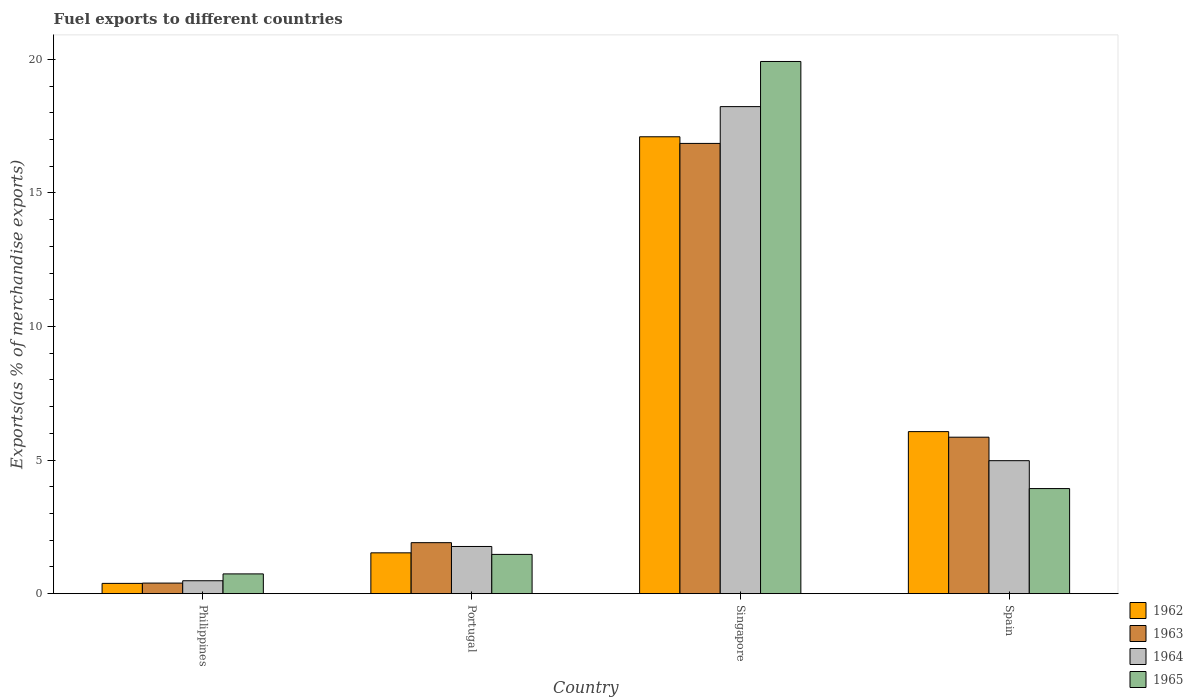How many different coloured bars are there?
Give a very brief answer. 4. How many groups of bars are there?
Your response must be concise. 4. Are the number of bars on each tick of the X-axis equal?
Your answer should be very brief. Yes. In how many cases, is the number of bars for a given country not equal to the number of legend labels?
Your answer should be very brief. 0. What is the percentage of exports to different countries in 1965 in Philippines?
Offer a very short reply. 0.74. Across all countries, what is the maximum percentage of exports to different countries in 1962?
Your answer should be compact. 17.1. Across all countries, what is the minimum percentage of exports to different countries in 1963?
Your response must be concise. 0.4. In which country was the percentage of exports to different countries in 1963 maximum?
Make the answer very short. Singapore. In which country was the percentage of exports to different countries in 1962 minimum?
Keep it short and to the point. Philippines. What is the total percentage of exports to different countries in 1962 in the graph?
Keep it short and to the point. 25.08. What is the difference between the percentage of exports to different countries in 1962 in Philippines and that in Portugal?
Provide a short and direct response. -1.14. What is the difference between the percentage of exports to different countries in 1962 in Philippines and the percentage of exports to different countries in 1963 in Portugal?
Provide a succinct answer. -1.52. What is the average percentage of exports to different countries in 1963 per country?
Offer a terse response. 6.25. What is the difference between the percentage of exports to different countries of/in 1965 and percentage of exports to different countries of/in 1962 in Philippines?
Your answer should be compact. 0.35. In how many countries, is the percentage of exports to different countries in 1962 greater than 7 %?
Ensure brevity in your answer.  1. What is the ratio of the percentage of exports to different countries in 1964 in Portugal to that in Singapore?
Your answer should be compact. 0.1. Is the difference between the percentage of exports to different countries in 1965 in Portugal and Singapore greater than the difference between the percentage of exports to different countries in 1962 in Portugal and Singapore?
Keep it short and to the point. No. What is the difference between the highest and the second highest percentage of exports to different countries in 1964?
Provide a succinct answer. -16.47. What is the difference between the highest and the lowest percentage of exports to different countries in 1965?
Ensure brevity in your answer.  19.18. In how many countries, is the percentage of exports to different countries in 1965 greater than the average percentage of exports to different countries in 1965 taken over all countries?
Keep it short and to the point. 1. Is the sum of the percentage of exports to different countries in 1962 in Philippines and Portugal greater than the maximum percentage of exports to different countries in 1965 across all countries?
Ensure brevity in your answer.  No. Is it the case that in every country, the sum of the percentage of exports to different countries in 1962 and percentage of exports to different countries in 1965 is greater than the sum of percentage of exports to different countries in 1963 and percentage of exports to different countries in 1964?
Keep it short and to the point. No. Is it the case that in every country, the sum of the percentage of exports to different countries in 1963 and percentage of exports to different countries in 1962 is greater than the percentage of exports to different countries in 1965?
Your answer should be compact. Yes. How many bars are there?
Give a very brief answer. 16. How many countries are there in the graph?
Make the answer very short. 4. Does the graph contain any zero values?
Your answer should be very brief. No. What is the title of the graph?
Keep it short and to the point. Fuel exports to different countries. Does "1990" appear as one of the legend labels in the graph?
Provide a succinct answer. No. What is the label or title of the X-axis?
Your response must be concise. Country. What is the label or title of the Y-axis?
Provide a short and direct response. Exports(as % of merchandise exports). What is the Exports(as % of merchandise exports) in 1962 in Philippines?
Offer a terse response. 0.38. What is the Exports(as % of merchandise exports) in 1963 in Philippines?
Provide a short and direct response. 0.4. What is the Exports(as % of merchandise exports) in 1964 in Philippines?
Give a very brief answer. 0.48. What is the Exports(as % of merchandise exports) in 1965 in Philippines?
Offer a terse response. 0.74. What is the Exports(as % of merchandise exports) of 1962 in Portugal?
Make the answer very short. 1.53. What is the Exports(as % of merchandise exports) in 1963 in Portugal?
Ensure brevity in your answer.  1.91. What is the Exports(as % of merchandise exports) in 1964 in Portugal?
Ensure brevity in your answer.  1.77. What is the Exports(as % of merchandise exports) in 1965 in Portugal?
Offer a very short reply. 1.47. What is the Exports(as % of merchandise exports) in 1962 in Singapore?
Ensure brevity in your answer.  17.1. What is the Exports(as % of merchandise exports) in 1963 in Singapore?
Offer a terse response. 16.85. What is the Exports(as % of merchandise exports) of 1964 in Singapore?
Give a very brief answer. 18.23. What is the Exports(as % of merchandise exports) of 1965 in Singapore?
Keep it short and to the point. 19.92. What is the Exports(as % of merchandise exports) in 1962 in Spain?
Provide a succinct answer. 6.07. What is the Exports(as % of merchandise exports) of 1963 in Spain?
Your answer should be very brief. 5.86. What is the Exports(as % of merchandise exports) of 1964 in Spain?
Provide a succinct answer. 4.98. What is the Exports(as % of merchandise exports) in 1965 in Spain?
Keep it short and to the point. 3.93. Across all countries, what is the maximum Exports(as % of merchandise exports) in 1962?
Offer a very short reply. 17.1. Across all countries, what is the maximum Exports(as % of merchandise exports) of 1963?
Your response must be concise. 16.85. Across all countries, what is the maximum Exports(as % of merchandise exports) in 1964?
Your answer should be very brief. 18.23. Across all countries, what is the maximum Exports(as % of merchandise exports) of 1965?
Offer a terse response. 19.92. Across all countries, what is the minimum Exports(as % of merchandise exports) of 1962?
Your answer should be very brief. 0.38. Across all countries, what is the minimum Exports(as % of merchandise exports) of 1963?
Make the answer very short. 0.4. Across all countries, what is the minimum Exports(as % of merchandise exports) in 1964?
Offer a terse response. 0.48. Across all countries, what is the minimum Exports(as % of merchandise exports) in 1965?
Offer a terse response. 0.74. What is the total Exports(as % of merchandise exports) in 1962 in the graph?
Offer a terse response. 25.08. What is the total Exports(as % of merchandise exports) of 1963 in the graph?
Your answer should be very brief. 25.02. What is the total Exports(as % of merchandise exports) in 1964 in the graph?
Keep it short and to the point. 25.46. What is the total Exports(as % of merchandise exports) in 1965 in the graph?
Offer a very short reply. 26.07. What is the difference between the Exports(as % of merchandise exports) of 1962 in Philippines and that in Portugal?
Make the answer very short. -1.14. What is the difference between the Exports(as % of merchandise exports) of 1963 in Philippines and that in Portugal?
Ensure brevity in your answer.  -1.51. What is the difference between the Exports(as % of merchandise exports) in 1964 in Philippines and that in Portugal?
Keep it short and to the point. -1.28. What is the difference between the Exports(as % of merchandise exports) of 1965 in Philippines and that in Portugal?
Offer a terse response. -0.73. What is the difference between the Exports(as % of merchandise exports) in 1962 in Philippines and that in Singapore?
Make the answer very short. -16.72. What is the difference between the Exports(as % of merchandise exports) of 1963 in Philippines and that in Singapore?
Provide a short and direct response. -16.46. What is the difference between the Exports(as % of merchandise exports) in 1964 in Philippines and that in Singapore?
Make the answer very short. -17.75. What is the difference between the Exports(as % of merchandise exports) of 1965 in Philippines and that in Singapore?
Your response must be concise. -19.18. What is the difference between the Exports(as % of merchandise exports) of 1962 in Philippines and that in Spain?
Your answer should be very brief. -5.68. What is the difference between the Exports(as % of merchandise exports) of 1963 in Philippines and that in Spain?
Provide a short and direct response. -5.46. What is the difference between the Exports(as % of merchandise exports) in 1964 in Philippines and that in Spain?
Provide a succinct answer. -4.49. What is the difference between the Exports(as % of merchandise exports) of 1965 in Philippines and that in Spain?
Provide a short and direct response. -3.19. What is the difference between the Exports(as % of merchandise exports) of 1962 in Portugal and that in Singapore?
Keep it short and to the point. -15.58. What is the difference between the Exports(as % of merchandise exports) in 1963 in Portugal and that in Singapore?
Ensure brevity in your answer.  -14.95. What is the difference between the Exports(as % of merchandise exports) of 1964 in Portugal and that in Singapore?
Offer a very short reply. -16.47. What is the difference between the Exports(as % of merchandise exports) in 1965 in Portugal and that in Singapore?
Your answer should be very brief. -18.45. What is the difference between the Exports(as % of merchandise exports) in 1962 in Portugal and that in Spain?
Give a very brief answer. -4.54. What is the difference between the Exports(as % of merchandise exports) in 1963 in Portugal and that in Spain?
Offer a very short reply. -3.95. What is the difference between the Exports(as % of merchandise exports) of 1964 in Portugal and that in Spain?
Keep it short and to the point. -3.21. What is the difference between the Exports(as % of merchandise exports) in 1965 in Portugal and that in Spain?
Your response must be concise. -2.46. What is the difference between the Exports(as % of merchandise exports) in 1962 in Singapore and that in Spain?
Provide a short and direct response. 11.04. What is the difference between the Exports(as % of merchandise exports) in 1963 in Singapore and that in Spain?
Your answer should be compact. 11. What is the difference between the Exports(as % of merchandise exports) of 1964 in Singapore and that in Spain?
Provide a succinct answer. 13.25. What is the difference between the Exports(as % of merchandise exports) in 1965 in Singapore and that in Spain?
Offer a terse response. 15.99. What is the difference between the Exports(as % of merchandise exports) of 1962 in Philippines and the Exports(as % of merchandise exports) of 1963 in Portugal?
Your answer should be compact. -1.52. What is the difference between the Exports(as % of merchandise exports) of 1962 in Philippines and the Exports(as % of merchandise exports) of 1964 in Portugal?
Your answer should be compact. -1.38. What is the difference between the Exports(as % of merchandise exports) of 1962 in Philippines and the Exports(as % of merchandise exports) of 1965 in Portugal?
Provide a short and direct response. -1.08. What is the difference between the Exports(as % of merchandise exports) of 1963 in Philippines and the Exports(as % of merchandise exports) of 1964 in Portugal?
Ensure brevity in your answer.  -1.37. What is the difference between the Exports(as % of merchandise exports) in 1963 in Philippines and the Exports(as % of merchandise exports) in 1965 in Portugal?
Make the answer very short. -1.07. What is the difference between the Exports(as % of merchandise exports) of 1964 in Philippines and the Exports(as % of merchandise exports) of 1965 in Portugal?
Provide a short and direct response. -0.99. What is the difference between the Exports(as % of merchandise exports) of 1962 in Philippines and the Exports(as % of merchandise exports) of 1963 in Singapore?
Your answer should be compact. -16.47. What is the difference between the Exports(as % of merchandise exports) of 1962 in Philippines and the Exports(as % of merchandise exports) of 1964 in Singapore?
Your response must be concise. -17.85. What is the difference between the Exports(as % of merchandise exports) in 1962 in Philippines and the Exports(as % of merchandise exports) in 1965 in Singapore?
Provide a succinct answer. -19.54. What is the difference between the Exports(as % of merchandise exports) in 1963 in Philippines and the Exports(as % of merchandise exports) in 1964 in Singapore?
Give a very brief answer. -17.84. What is the difference between the Exports(as % of merchandise exports) of 1963 in Philippines and the Exports(as % of merchandise exports) of 1965 in Singapore?
Offer a very short reply. -19.53. What is the difference between the Exports(as % of merchandise exports) in 1964 in Philippines and the Exports(as % of merchandise exports) in 1965 in Singapore?
Provide a short and direct response. -19.44. What is the difference between the Exports(as % of merchandise exports) in 1962 in Philippines and the Exports(as % of merchandise exports) in 1963 in Spain?
Offer a very short reply. -5.47. What is the difference between the Exports(as % of merchandise exports) of 1962 in Philippines and the Exports(as % of merchandise exports) of 1964 in Spain?
Offer a very short reply. -4.59. What is the difference between the Exports(as % of merchandise exports) in 1962 in Philippines and the Exports(as % of merchandise exports) in 1965 in Spain?
Give a very brief answer. -3.55. What is the difference between the Exports(as % of merchandise exports) in 1963 in Philippines and the Exports(as % of merchandise exports) in 1964 in Spain?
Your response must be concise. -4.58. What is the difference between the Exports(as % of merchandise exports) in 1963 in Philippines and the Exports(as % of merchandise exports) in 1965 in Spain?
Ensure brevity in your answer.  -3.54. What is the difference between the Exports(as % of merchandise exports) of 1964 in Philippines and the Exports(as % of merchandise exports) of 1965 in Spain?
Offer a very short reply. -3.45. What is the difference between the Exports(as % of merchandise exports) of 1962 in Portugal and the Exports(as % of merchandise exports) of 1963 in Singapore?
Provide a short and direct response. -15.33. What is the difference between the Exports(as % of merchandise exports) of 1962 in Portugal and the Exports(as % of merchandise exports) of 1964 in Singapore?
Your answer should be very brief. -16.7. What is the difference between the Exports(as % of merchandise exports) of 1962 in Portugal and the Exports(as % of merchandise exports) of 1965 in Singapore?
Your answer should be compact. -18.39. What is the difference between the Exports(as % of merchandise exports) of 1963 in Portugal and the Exports(as % of merchandise exports) of 1964 in Singapore?
Offer a terse response. -16.32. What is the difference between the Exports(as % of merchandise exports) in 1963 in Portugal and the Exports(as % of merchandise exports) in 1965 in Singapore?
Give a very brief answer. -18.01. What is the difference between the Exports(as % of merchandise exports) of 1964 in Portugal and the Exports(as % of merchandise exports) of 1965 in Singapore?
Keep it short and to the point. -18.16. What is the difference between the Exports(as % of merchandise exports) in 1962 in Portugal and the Exports(as % of merchandise exports) in 1963 in Spain?
Your response must be concise. -4.33. What is the difference between the Exports(as % of merchandise exports) of 1962 in Portugal and the Exports(as % of merchandise exports) of 1964 in Spain?
Offer a terse response. -3.45. What is the difference between the Exports(as % of merchandise exports) in 1962 in Portugal and the Exports(as % of merchandise exports) in 1965 in Spain?
Ensure brevity in your answer.  -2.41. What is the difference between the Exports(as % of merchandise exports) in 1963 in Portugal and the Exports(as % of merchandise exports) in 1964 in Spain?
Your answer should be very brief. -3.07. What is the difference between the Exports(as % of merchandise exports) of 1963 in Portugal and the Exports(as % of merchandise exports) of 1965 in Spain?
Provide a short and direct response. -2.03. What is the difference between the Exports(as % of merchandise exports) in 1964 in Portugal and the Exports(as % of merchandise exports) in 1965 in Spain?
Your answer should be very brief. -2.17. What is the difference between the Exports(as % of merchandise exports) in 1962 in Singapore and the Exports(as % of merchandise exports) in 1963 in Spain?
Your answer should be very brief. 11.25. What is the difference between the Exports(as % of merchandise exports) of 1962 in Singapore and the Exports(as % of merchandise exports) of 1964 in Spain?
Make the answer very short. 12.13. What is the difference between the Exports(as % of merchandise exports) of 1962 in Singapore and the Exports(as % of merchandise exports) of 1965 in Spain?
Ensure brevity in your answer.  13.17. What is the difference between the Exports(as % of merchandise exports) in 1963 in Singapore and the Exports(as % of merchandise exports) in 1964 in Spain?
Give a very brief answer. 11.88. What is the difference between the Exports(as % of merchandise exports) in 1963 in Singapore and the Exports(as % of merchandise exports) in 1965 in Spain?
Ensure brevity in your answer.  12.92. What is the difference between the Exports(as % of merchandise exports) in 1964 in Singapore and the Exports(as % of merchandise exports) in 1965 in Spain?
Provide a succinct answer. 14.3. What is the average Exports(as % of merchandise exports) of 1962 per country?
Your response must be concise. 6.27. What is the average Exports(as % of merchandise exports) in 1963 per country?
Give a very brief answer. 6.25. What is the average Exports(as % of merchandise exports) of 1964 per country?
Ensure brevity in your answer.  6.37. What is the average Exports(as % of merchandise exports) in 1965 per country?
Offer a very short reply. 6.52. What is the difference between the Exports(as % of merchandise exports) in 1962 and Exports(as % of merchandise exports) in 1963 in Philippines?
Keep it short and to the point. -0.01. What is the difference between the Exports(as % of merchandise exports) in 1962 and Exports(as % of merchandise exports) in 1964 in Philippines?
Keep it short and to the point. -0.1. What is the difference between the Exports(as % of merchandise exports) in 1962 and Exports(as % of merchandise exports) in 1965 in Philippines?
Your response must be concise. -0.35. What is the difference between the Exports(as % of merchandise exports) of 1963 and Exports(as % of merchandise exports) of 1964 in Philippines?
Offer a terse response. -0.09. What is the difference between the Exports(as % of merchandise exports) of 1963 and Exports(as % of merchandise exports) of 1965 in Philippines?
Your response must be concise. -0.34. What is the difference between the Exports(as % of merchandise exports) of 1964 and Exports(as % of merchandise exports) of 1965 in Philippines?
Offer a terse response. -0.26. What is the difference between the Exports(as % of merchandise exports) in 1962 and Exports(as % of merchandise exports) in 1963 in Portugal?
Your answer should be very brief. -0.38. What is the difference between the Exports(as % of merchandise exports) of 1962 and Exports(as % of merchandise exports) of 1964 in Portugal?
Make the answer very short. -0.24. What is the difference between the Exports(as % of merchandise exports) in 1962 and Exports(as % of merchandise exports) in 1965 in Portugal?
Offer a very short reply. 0.06. What is the difference between the Exports(as % of merchandise exports) of 1963 and Exports(as % of merchandise exports) of 1964 in Portugal?
Offer a terse response. 0.14. What is the difference between the Exports(as % of merchandise exports) of 1963 and Exports(as % of merchandise exports) of 1965 in Portugal?
Your answer should be compact. 0.44. What is the difference between the Exports(as % of merchandise exports) in 1964 and Exports(as % of merchandise exports) in 1965 in Portugal?
Provide a short and direct response. 0.3. What is the difference between the Exports(as % of merchandise exports) of 1962 and Exports(as % of merchandise exports) of 1963 in Singapore?
Give a very brief answer. 0.25. What is the difference between the Exports(as % of merchandise exports) in 1962 and Exports(as % of merchandise exports) in 1964 in Singapore?
Offer a terse response. -1.13. What is the difference between the Exports(as % of merchandise exports) in 1962 and Exports(as % of merchandise exports) in 1965 in Singapore?
Your answer should be very brief. -2.82. What is the difference between the Exports(as % of merchandise exports) in 1963 and Exports(as % of merchandise exports) in 1964 in Singapore?
Provide a succinct answer. -1.38. What is the difference between the Exports(as % of merchandise exports) of 1963 and Exports(as % of merchandise exports) of 1965 in Singapore?
Make the answer very short. -3.07. What is the difference between the Exports(as % of merchandise exports) in 1964 and Exports(as % of merchandise exports) in 1965 in Singapore?
Give a very brief answer. -1.69. What is the difference between the Exports(as % of merchandise exports) of 1962 and Exports(as % of merchandise exports) of 1963 in Spain?
Your answer should be very brief. 0.21. What is the difference between the Exports(as % of merchandise exports) in 1962 and Exports(as % of merchandise exports) in 1964 in Spain?
Your answer should be very brief. 1.09. What is the difference between the Exports(as % of merchandise exports) of 1962 and Exports(as % of merchandise exports) of 1965 in Spain?
Offer a terse response. 2.13. What is the difference between the Exports(as % of merchandise exports) of 1963 and Exports(as % of merchandise exports) of 1964 in Spain?
Offer a very short reply. 0.88. What is the difference between the Exports(as % of merchandise exports) of 1963 and Exports(as % of merchandise exports) of 1965 in Spain?
Your answer should be compact. 1.92. What is the difference between the Exports(as % of merchandise exports) of 1964 and Exports(as % of merchandise exports) of 1965 in Spain?
Provide a short and direct response. 1.04. What is the ratio of the Exports(as % of merchandise exports) in 1962 in Philippines to that in Portugal?
Keep it short and to the point. 0.25. What is the ratio of the Exports(as % of merchandise exports) of 1963 in Philippines to that in Portugal?
Offer a very short reply. 0.21. What is the ratio of the Exports(as % of merchandise exports) of 1964 in Philippines to that in Portugal?
Your answer should be compact. 0.27. What is the ratio of the Exports(as % of merchandise exports) in 1965 in Philippines to that in Portugal?
Provide a succinct answer. 0.5. What is the ratio of the Exports(as % of merchandise exports) in 1962 in Philippines to that in Singapore?
Provide a succinct answer. 0.02. What is the ratio of the Exports(as % of merchandise exports) of 1963 in Philippines to that in Singapore?
Offer a terse response. 0.02. What is the ratio of the Exports(as % of merchandise exports) of 1964 in Philippines to that in Singapore?
Your answer should be very brief. 0.03. What is the ratio of the Exports(as % of merchandise exports) in 1965 in Philippines to that in Singapore?
Ensure brevity in your answer.  0.04. What is the ratio of the Exports(as % of merchandise exports) in 1962 in Philippines to that in Spain?
Your answer should be compact. 0.06. What is the ratio of the Exports(as % of merchandise exports) in 1963 in Philippines to that in Spain?
Provide a short and direct response. 0.07. What is the ratio of the Exports(as % of merchandise exports) in 1964 in Philippines to that in Spain?
Provide a short and direct response. 0.1. What is the ratio of the Exports(as % of merchandise exports) of 1965 in Philippines to that in Spain?
Offer a terse response. 0.19. What is the ratio of the Exports(as % of merchandise exports) in 1962 in Portugal to that in Singapore?
Ensure brevity in your answer.  0.09. What is the ratio of the Exports(as % of merchandise exports) of 1963 in Portugal to that in Singapore?
Offer a very short reply. 0.11. What is the ratio of the Exports(as % of merchandise exports) in 1964 in Portugal to that in Singapore?
Provide a short and direct response. 0.1. What is the ratio of the Exports(as % of merchandise exports) of 1965 in Portugal to that in Singapore?
Your response must be concise. 0.07. What is the ratio of the Exports(as % of merchandise exports) in 1962 in Portugal to that in Spain?
Offer a very short reply. 0.25. What is the ratio of the Exports(as % of merchandise exports) of 1963 in Portugal to that in Spain?
Keep it short and to the point. 0.33. What is the ratio of the Exports(as % of merchandise exports) of 1964 in Portugal to that in Spain?
Provide a succinct answer. 0.35. What is the ratio of the Exports(as % of merchandise exports) of 1965 in Portugal to that in Spain?
Provide a short and direct response. 0.37. What is the ratio of the Exports(as % of merchandise exports) in 1962 in Singapore to that in Spain?
Make the answer very short. 2.82. What is the ratio of the Exports(as % of merchandise exports) of 1963 in Singapore to that in Spain?
Give a very brief answer. 2.88. What is the ratio of the Exports(as % of merchandise exports) of 1964 in Singapore to that in Spain?
Your answer should be very brief. 3.66. What is the ratio of the Exports(as % of merchandise exports) in 1965 in Singapore to that in Spain?
Keep it short and to the point. 5.06. What is the difference between the highest and the second highest Exports(as % of merchandise exports) in 1962?
Keep it short and to the point. 11.04. What is the difference between the highest and the second highest Exports(as % of merchandise exports) of 1963?
Ensure brevity in your answer.  11. What is the difference between the highest and the second highest Exports(as % of merchandise exports) of 1964?
Your answer should be compact. 13.25. What is the difference between the highest and the second highest Exports(as % of merchandise exports) of 1965?
Provide a succinct answer. 15.99. What is the difference between the highest and the lowest Exports(as % of merchandise exports) of 1962?
Provide a short and direct response. 16.72. What is the difference between the highest and the lowest Exports(as % of merchandise exports) in 1963?
Ensure brevity in your answer.  16.46. What is the difference between the highest and the lowest Exports(as % of merchandise exports) of 1964?
Keep it short and to the point. 17.75. What is the difference between the highest and the lowest Exports(as % of merchandise exports) of 1965?
Offer a very short reply. 19.18. 